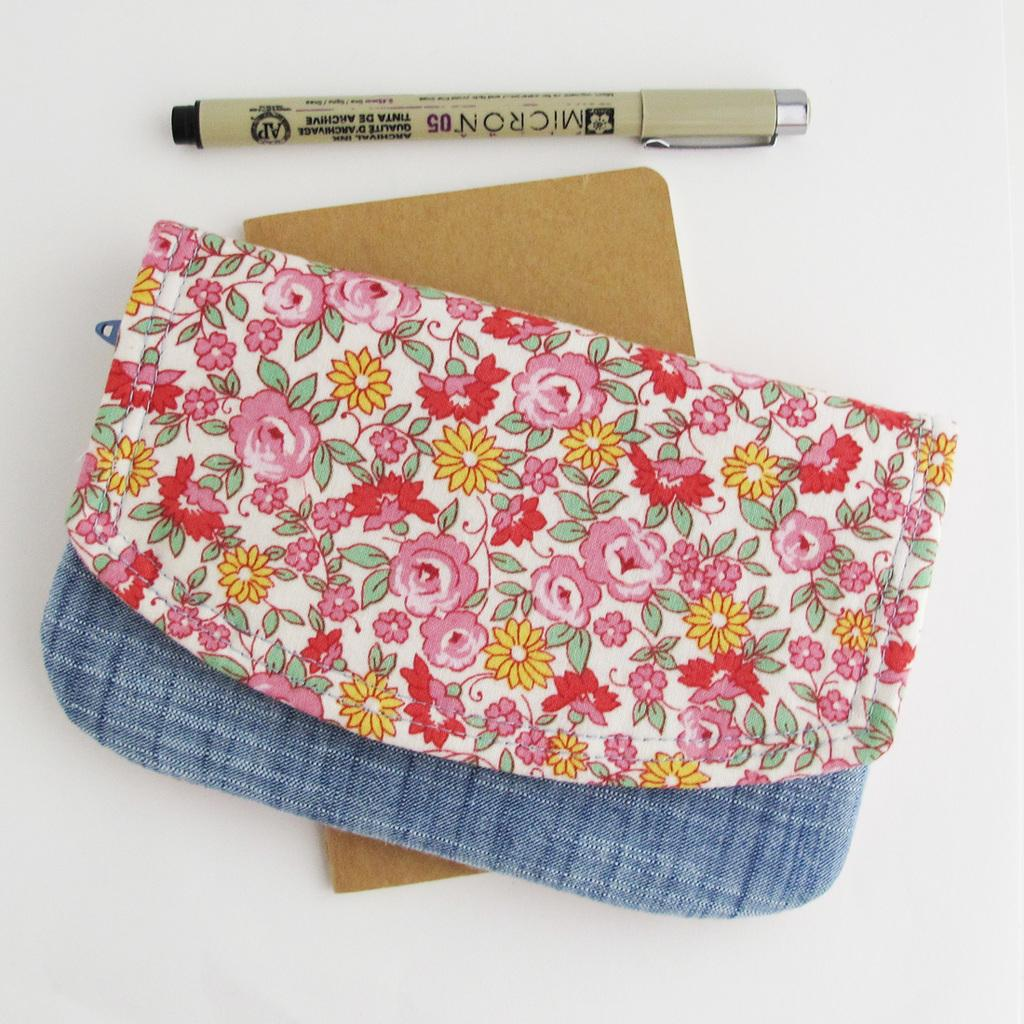What type of accessory is present in the image? There is a colorful purse in the image. What colors can be seen on the purse? The purse has blue, pink, red, and yellow colors. What other object is present in the image? There is a brown color board in the image. What stationery item can be seen in the image? There is a pen in the image. What type of noise can be heard coming from the purse in the image? There is no noise coming from the purse in the image, as it is an inanimate object. 